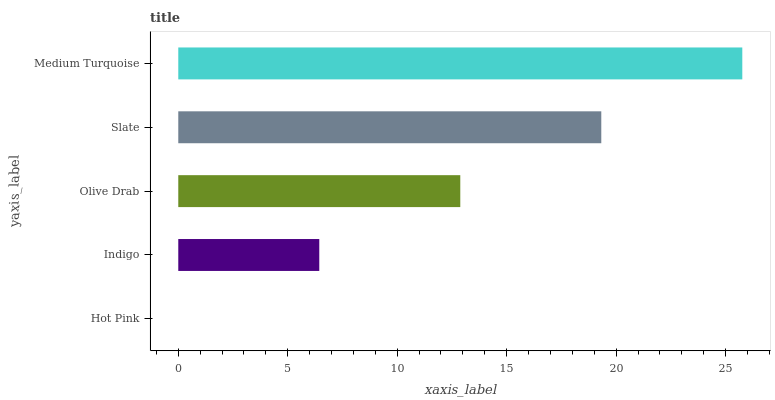Is Hot Pink the minimum?
Answer yes or no. Yes. Is Medium Turquoise the maximum?
Answer yes or no. Yes. Is Indigo the minimum?
Answer yes or no. No. Is Indigo the maximum?
Answer yes or no. No. Is Indigo greater than Hot Pink?
Answer yes or no. Yes. Is Hot Pink less than Indigo?
Answer yes or no. Yes. Is Hot Pink greater than Indigo?
Answer yes or no. No. Is Indigo less than Hot Pink?
Answer yes or no. No. Is Olive Drab the high median?
Answer yes or no. Yes. Is Olive Drab the low median?
Answer yes or no. Yes. Is Medium Turquoise the high median?
Answer yes or no. No. Is Hot Pink the low median?
Answer yes or no. No. 